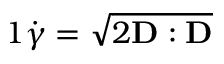Convert formula to latex. <formula><loc_0><loc_0><loc_500><loc_500>\begin{array} { r } { { 1 } \dot { \gamma } = \sqrt { 2 D \colon D } } \end{array}</formula> 